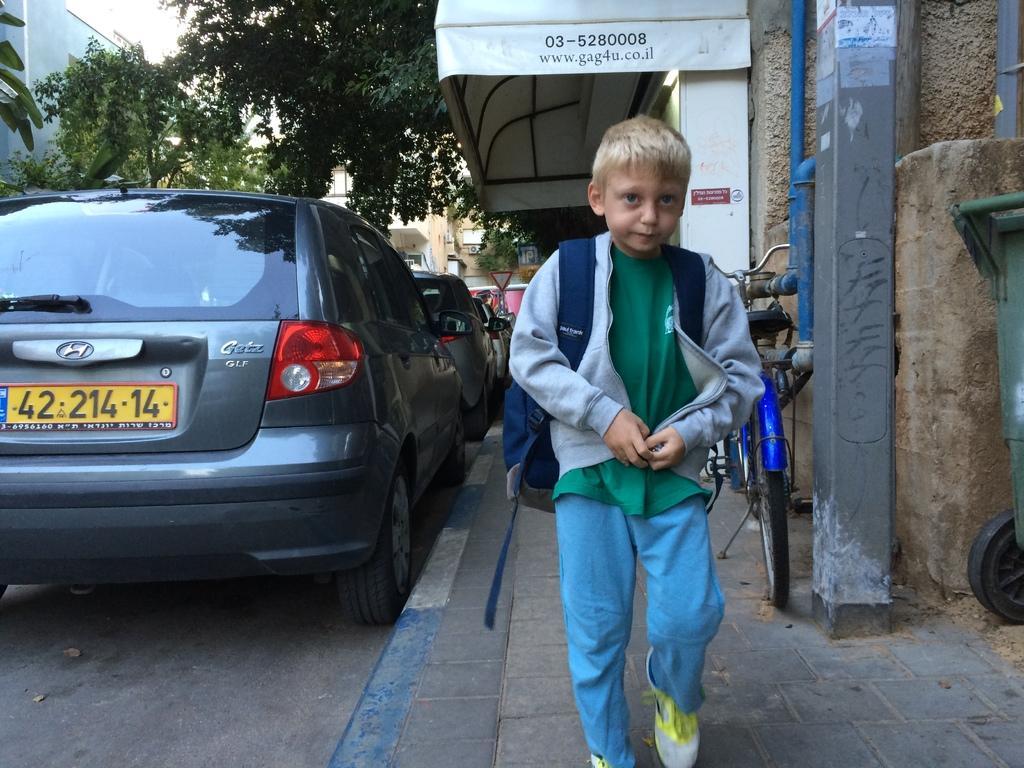In one or two sentences, can you explain what this image depicts? In this image a kid is walking on a footpath, beside that footpath there are cars parked, on right side there is a bicycle, in the background there are trees and houses. 